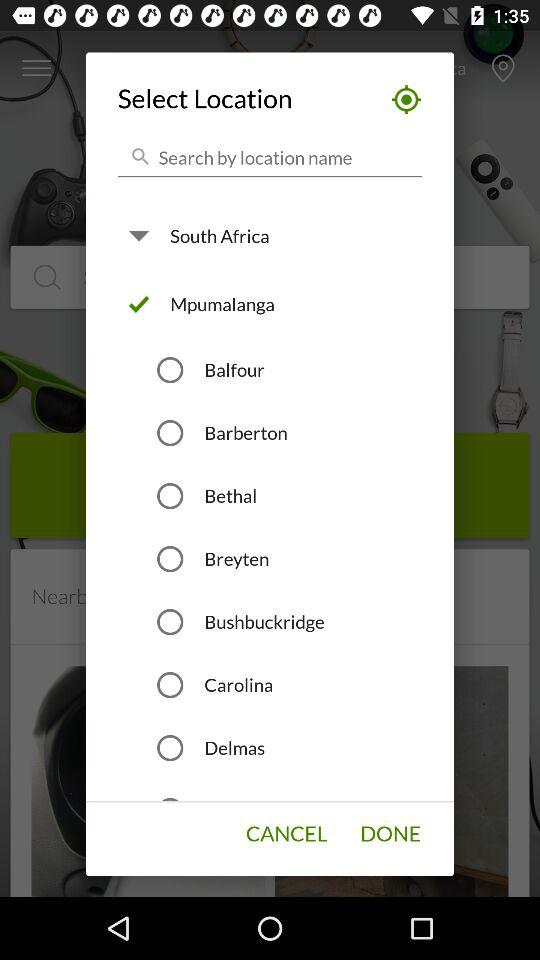Is "Bethal" selected or not? "Bethal" is not selected. 